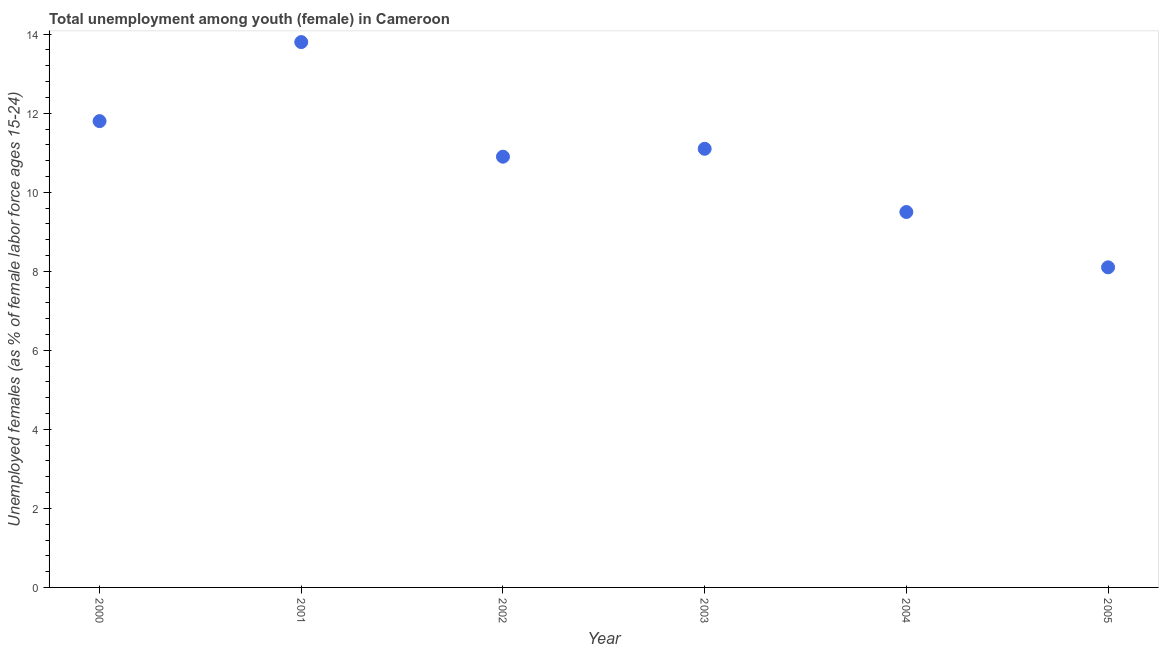What is the unemployed female youth population in 2001?
Your response must be concise. 13.8. Across all years, what is the maximum unemployed female youth population?
Your response must be concise. 13.8. Across all years, what is the minimum unemployed female youth population?
Make the answer very short. 8.1. In which year was the unemployed female youth population maximum?
Keep it short and to the point. 2001. What is the sum of the unemployed female youth population?
Provide a short and direct response. 65.2. What is the difference between the unemployed female youth population in 2001 and 2004?
Your response must be concise. 4.3. What is the average unemployed female youth population per year?
Ensure brevity in your answer.  10.87. In how many years, is the unemployed female youth population greater than 13.6 %?
Your answer should be very brief. 1. Do a majority of the years between 2005 and 2000 (inclusive) have unemployed female youth population greater than 11.6 %?
Keep it short and to the point. Yes. What is the ratio of the unemployed female youth population in 2000 to that in 2001?
Provide a short and direct response. 0.86. What is the difference between the highest and the second highest unemployed female youth population?
Offer a terse response. 2. Is the sum of the unemployed female youth population in 2002 and 2005 greater than the maximum unemployed female youth population across all years?
Offer a terse response. Yes. What is the difference between the highest and the lowest unemployed female youth population?
Your answer should be very brief. 5.7. Does the unemployed female youth population monotonically increase over the years?
Ensure brevity in your answer.  No. What is the difference between two consecutive major ticks on the Y-axis?
Ensure brevity in your answer.  2. Are the values on the major ticks of Y-axis written in scientific E-notation?
Make the answer very short. No. What is the title of the graph?
Provide a short and direct response. Total unemployment among youth (female) in Cameroon. What is the label or title of the Y-axis?
Give a very brief answer. Unemployed females (as % of female labor force ages 15-24). What is the Unemployed females (as % of female labor force ages 15-24) in 2000?
Provide a short and direct response. 11.8. What is the Unemployed females (as % of female labor force ages 15-24) in 2001?
Offer a very short reply. 13.8. What is the Unemployed females (as % of female labor force ages 15-24) in 2002?
Your answer should be compact. 10.9. What is the Unemployed females (as % of female labor force ages 15-24) in 2003?
Provide a succinct answer. 11.1. What is the Unemployed females (as % of female labor force ages 15-24) in 2004?
Offer a terse response. 9.5. What is the Unemployed females (as % of female labor force ages 15-24) in 2005?
Ensure brevity in your answer.  8.1. What is the difference between the Unemployed females (as % of female labor force ages 15-24) in 2000 and 2001?
Your response must be concise. -2. What is the difference between the Unemployed females (as % of female labor force ages 15-24) in 2000 and 2002?
Provide a succinct answer. 0.9. What is the difference between the Unemployed females (as % of female labor force ages 15-24) in 2000 and 2005?
Keep it short and to the point. 3.7. What is the difference between the Unemployed females (as % of female labor force ages 15-24) in 2001 and 2003?
Your answer should be compact. 2.7. What is the difference between the Unemployed females (as % of female labor force ages 15-24) in 2001 and 2004?
Your response must be concise. 4.3. What is the difference between the Unemployed females (as % of female labor force ages 15-24) in 2002 and 2003?
Ensure brevity in your answer.  -0.2. What is the difference between the Unemployed females (as % of female labor force ages 15-24) in 2002 and 2005?
Provide a short and direct response. 2.8. What is the difference between the Unemployed females (as % of female labor force ages 15-24) in 2003 and 2005?
Your response must be concise. 3. What is the difference between the Unemployed females (as % of female labor force ages 15-24) in 2004 and 2005?
Keep it short and to the point. 1.4. What is the ratio of the Unemployed females (as % of female labor force ages 15-24) in 2000 to that in 2001?
Keep it short and to the point. 0.85. What is the ratio of the Unemployed females (as % of female labor force ages 15-24) in 2000 to that in 2002?
Offer a terse response. 1.08. What is the ratio of the Unemployed females (as % of female labor force ages 15-24) in 2000 to that in 2003?
Keep it short and to the point. 1.06. What is the ratio of the Unemployed females (as % of female labor force ages 15-24) in 2000 to that in 2004?
Offer a very short reply. 1.24. What is the ratio of the Unemployed females (as % of female labor force ages 15-24) in 2000 to that in 2005?
Ensure brevity in your answer.  1.46. What is the ratio of the Unemployed females (as % of female labor force ages 15-24) in 2001 to that in 2002?
Offer a terse response. 1.27. What is the ratio of the Unemployed females (as % of female labor force ages 15-24) in 2001 to that in 2003?
Offer a very short reply. 1.24. What is the ratio of the Unemployed females (as % of female labor force ages 15-24) in 2001 to that in 2004?
Your answer should be compact. 1.45. What is the ratio of the Unemployed females (as % of female labor force ages 15-24) in 2001 to that in 2005?
Your answer should be compact. 1.7. What is the ratio of the Unemployed females (as % of female labor force ages 15-24) in 2002 to that in 2004?
Ensure brevity in your answer.  1.15. What is the ratio of the Unemployed females (as % of female labor force ages 15-24) in 2002 to that in 2005?
Your answer should be very brief. 1.35. What is the ratio of the Unemployed females (as % of female labor force ages 15-24) in 2003 to that in 2004?
Keep it short and to the point. 1.17. What is the ratio of the Unemployed females (as % of female labor force ages 15-24) in 2003 to that in 2005?
Your response must be concise. 1.37. What is the ratio of the Unemployed females (as % of female labor force ages 15-24) in 2004 to that in 2005?
Provide a succinct answer. 1.17. 